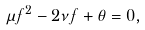<formula> <loc_0><loc_0><loc_500><loc_500>\mu f ^ { 2 } - 2 \nu f + \theta = 0 ,</formula> 